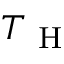<formula> <loc_0><loc_0><loc_500><loc_500>T _ { H }</formula> 